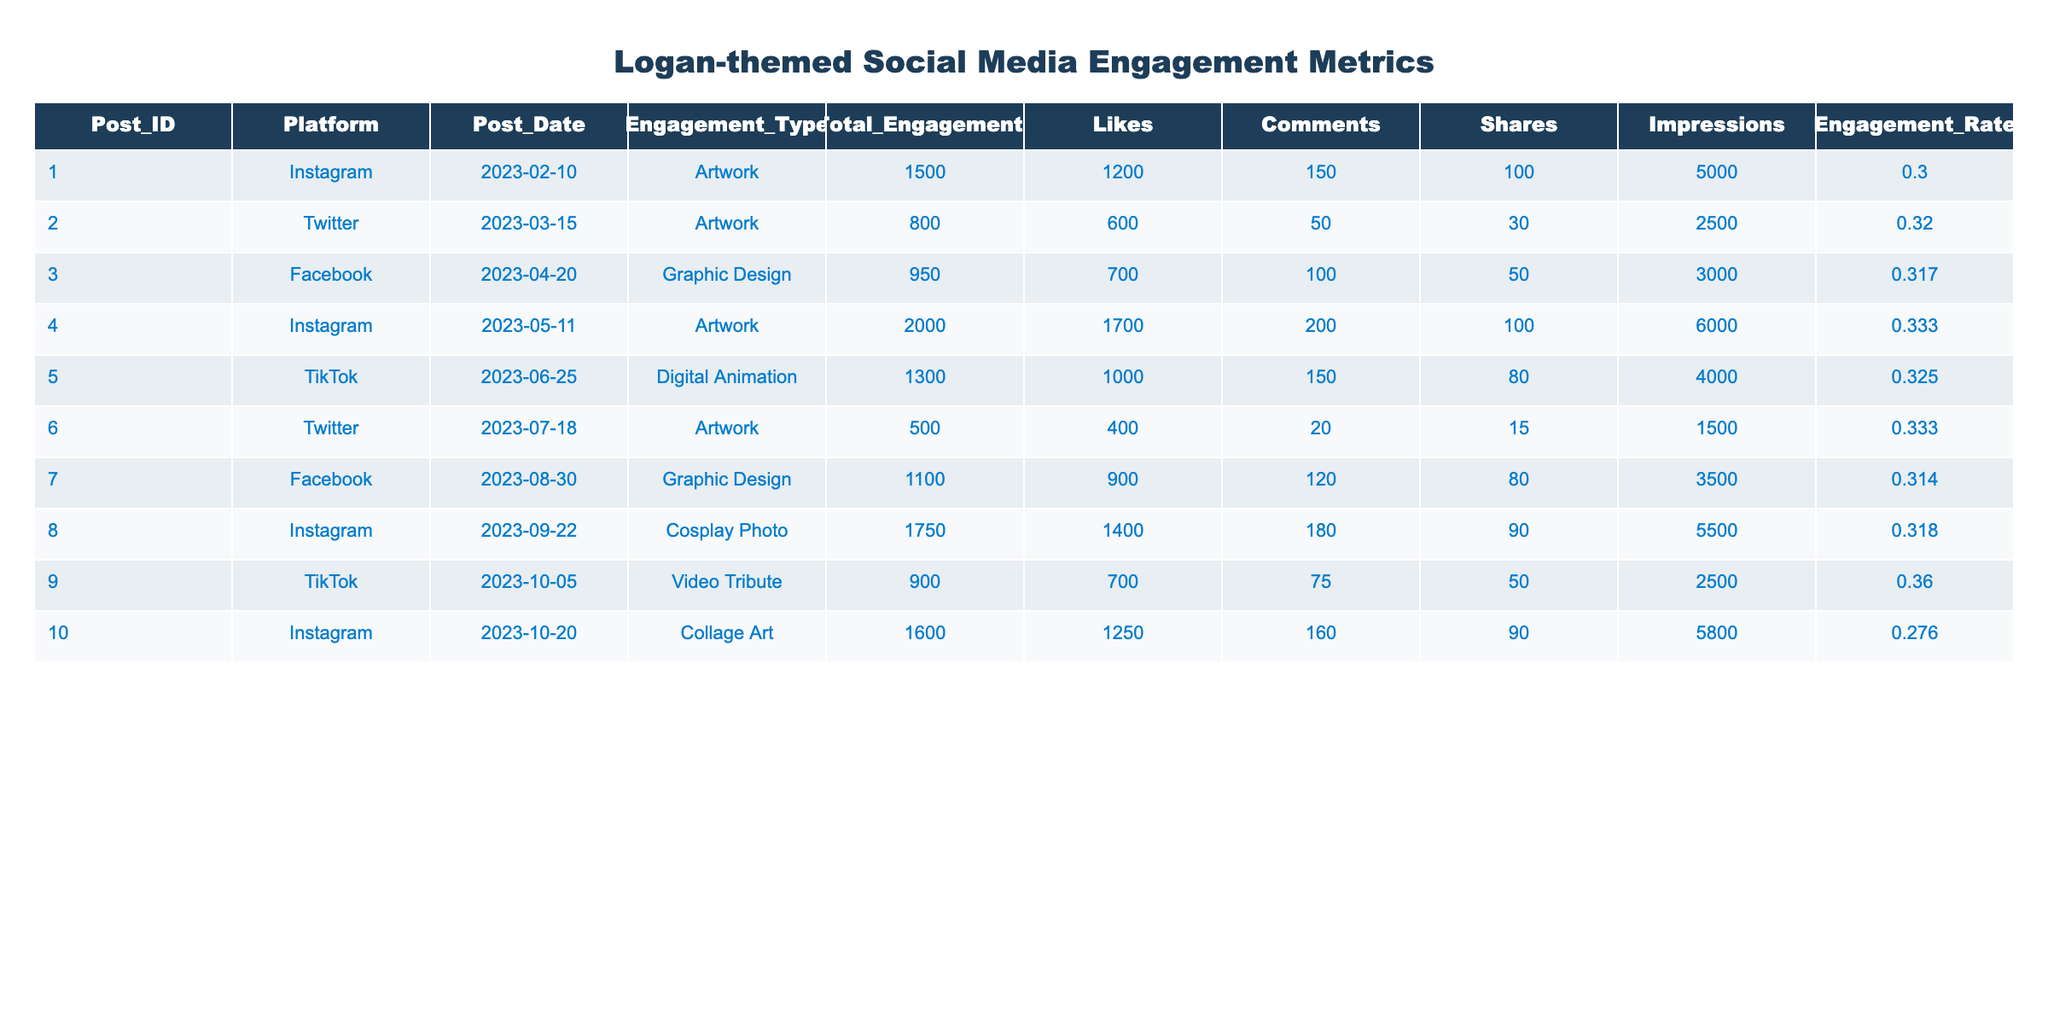What is the total number of engagements for the Instagram post dated 2023-05-11? Referring to the table, the total engagements for the Instagram post dated 2023-05-11 is indicated as 2000 under the Total Engagements column.
Answer: 2000 Which platform had the highest number of total engagements? By analyzing the Total Engagements column, Instagram has the highest value of 2000 among all entries.
Answer: Instagram What is the average number of likes across all posts on TikTok? The likes for TikTok posts are 1000 and 700, which totals to 1700 likes. There are 2 posts, so the average is 1700/2 = 850.
Answer: 850 Did the post on Facebook dated 2023-04-20 receive more likes than the post on Twitter dated 2023-07-18? The Facebook post received 700 likes, while the Twitter post received 400 likes. Since 700 is greater than 400, the statement is true.
Answer: Yes What was the engagement rate for the artwork posted on Instagram on 2023-02-10? To find the engagement rate, we divide the total engagements of 1500 by impressions of 5000, resulting in 0.3 when rounded to three decimal places.
Answer: 0.3 Which type of post had the least total engagements? By comparing the Total Engagements column, the Twitter post dated 2023-07-18 had the least total engagements at 500.
Answer: 500 What is the difference in shares between the Instagram post on 2023-05-11 and the TikTok post on 2023-10-05? The shares for the Instagram post are 100 and for the TikTok post, 50. The difference is calculated as 100 - 50 = 50.
Answer: 50 How many total impressions were recorded for Facebook posts? The impressions for Facebook posts are 3000 and 3500. Adding them gives 3000 + 3500 = 6500.
Answer: 6500 Was there any post that achieved more than 180 likes but less than 2000 total engagements? The posts that meet this condition are the TikTok Digital Animation post (likes: 1000, engagements: 1300) and Facebook Graphic Design post (likes: 900, engagements: 1100). Therefore, there are posts that fulfill the condition.
Answer: Yes 